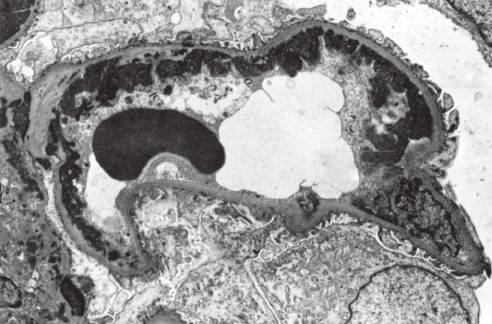do thrombus in the left and right ventricular apices correspond to wire loops seen by light microscopy?
Answer the question using a single word or phrase. No 